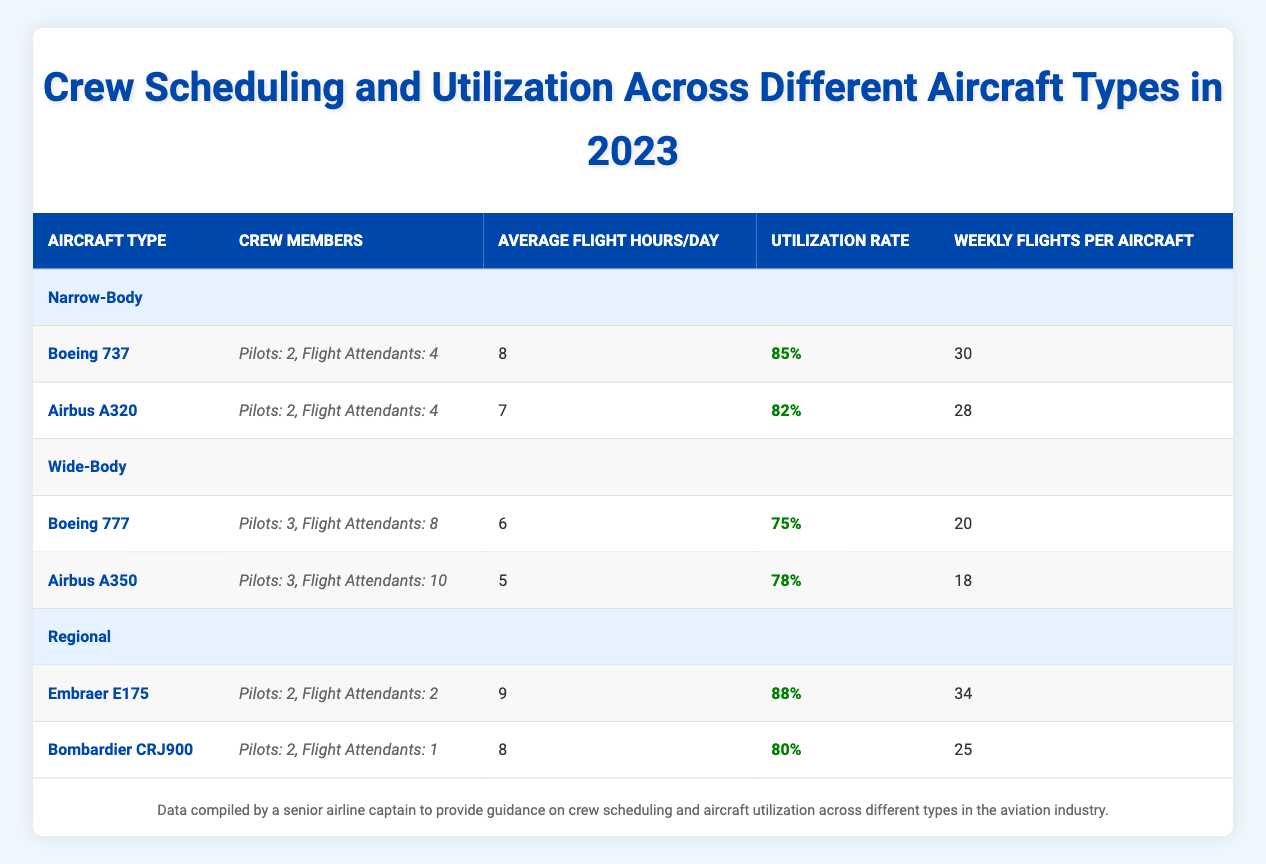What is the utilization rate of the Boeing 737? The utilization rate can be found directly from the data provided for the Boeing 737 under the Narrow-Body category. It is specified as 85%.
Answer: 85% How many crew members are needed for the Airbus A350? For the Airbus A350, the crew members needed are listed. There are 3 Pilots and 10 Flight Attendants, making a total of 13 crew members.
Answer: 13 What is the average flight hours per day for Regional aircraft? The average flight hours for Regional aircraft are provided for each type. The Embraer E175 has 9 hours, and the Bombardier CRJ900 has 8 hours. To find the average, we calculate (9 + 8) / 2 = 8.5 hours.
Answer: 8.5 Which aircraft type has the highest utilization rate? The utilization rates for all aircraft types are listed. The Embraer E175 has the highest at 88%. We compare all rates: 85% for Boeing 737, 82% for Airbus A320, 75% for Boeing 777, 78% for Airbus A350, 88% for Embraer E175, and 80% for Bombardier CRJ900. Thus, the Embraer E175 has the highest utilization rate.
Answer: Embraer E175 Is the average flight hours for the Wide-Body category less than that of the Narrow-Body category? To answer this, we first find the averages for both categories. For Wide-Body, the average is (6 + 5) / 2 = 5.5 hours. For Narrow-Body, the average is (8 + 7) / 2 = 7.5 hours. Since 5.5 hours is less than 7.5 hours, the statement is true.
Answer: Yes 